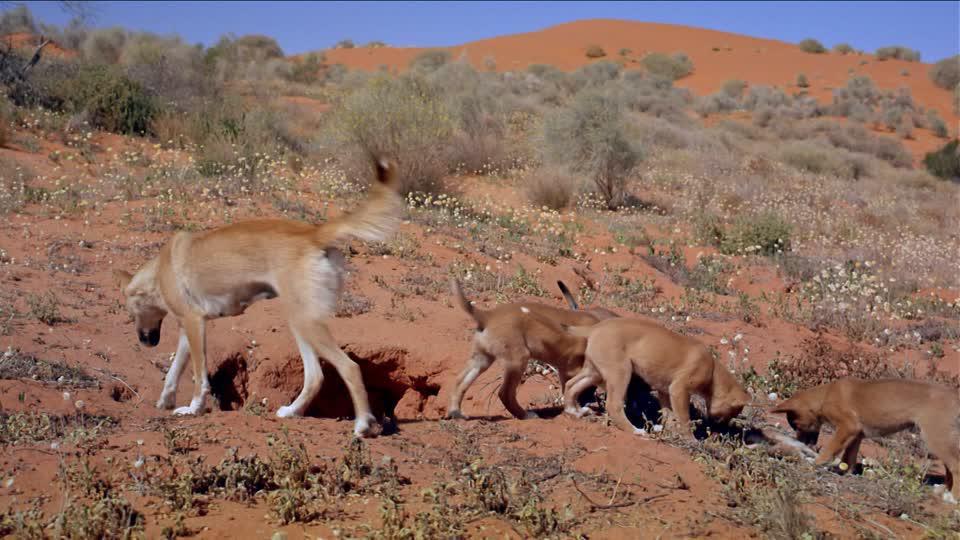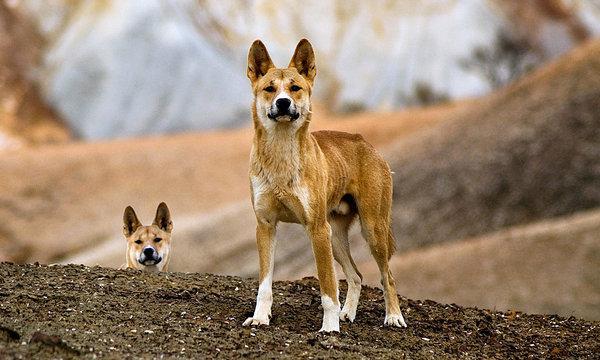The first image is the image on the left, the second image is the image on the right. Assess this claim about the two images: "Multiple dingos are at the edge of a body of water in one image.". Correct or not? Answer yes or no. No. The first image is the image on the left, the second image is the image on the right. For the images shown, is this caption "The dogs in one of the images are near a natural body of water." true? Answer yes or no. No. 